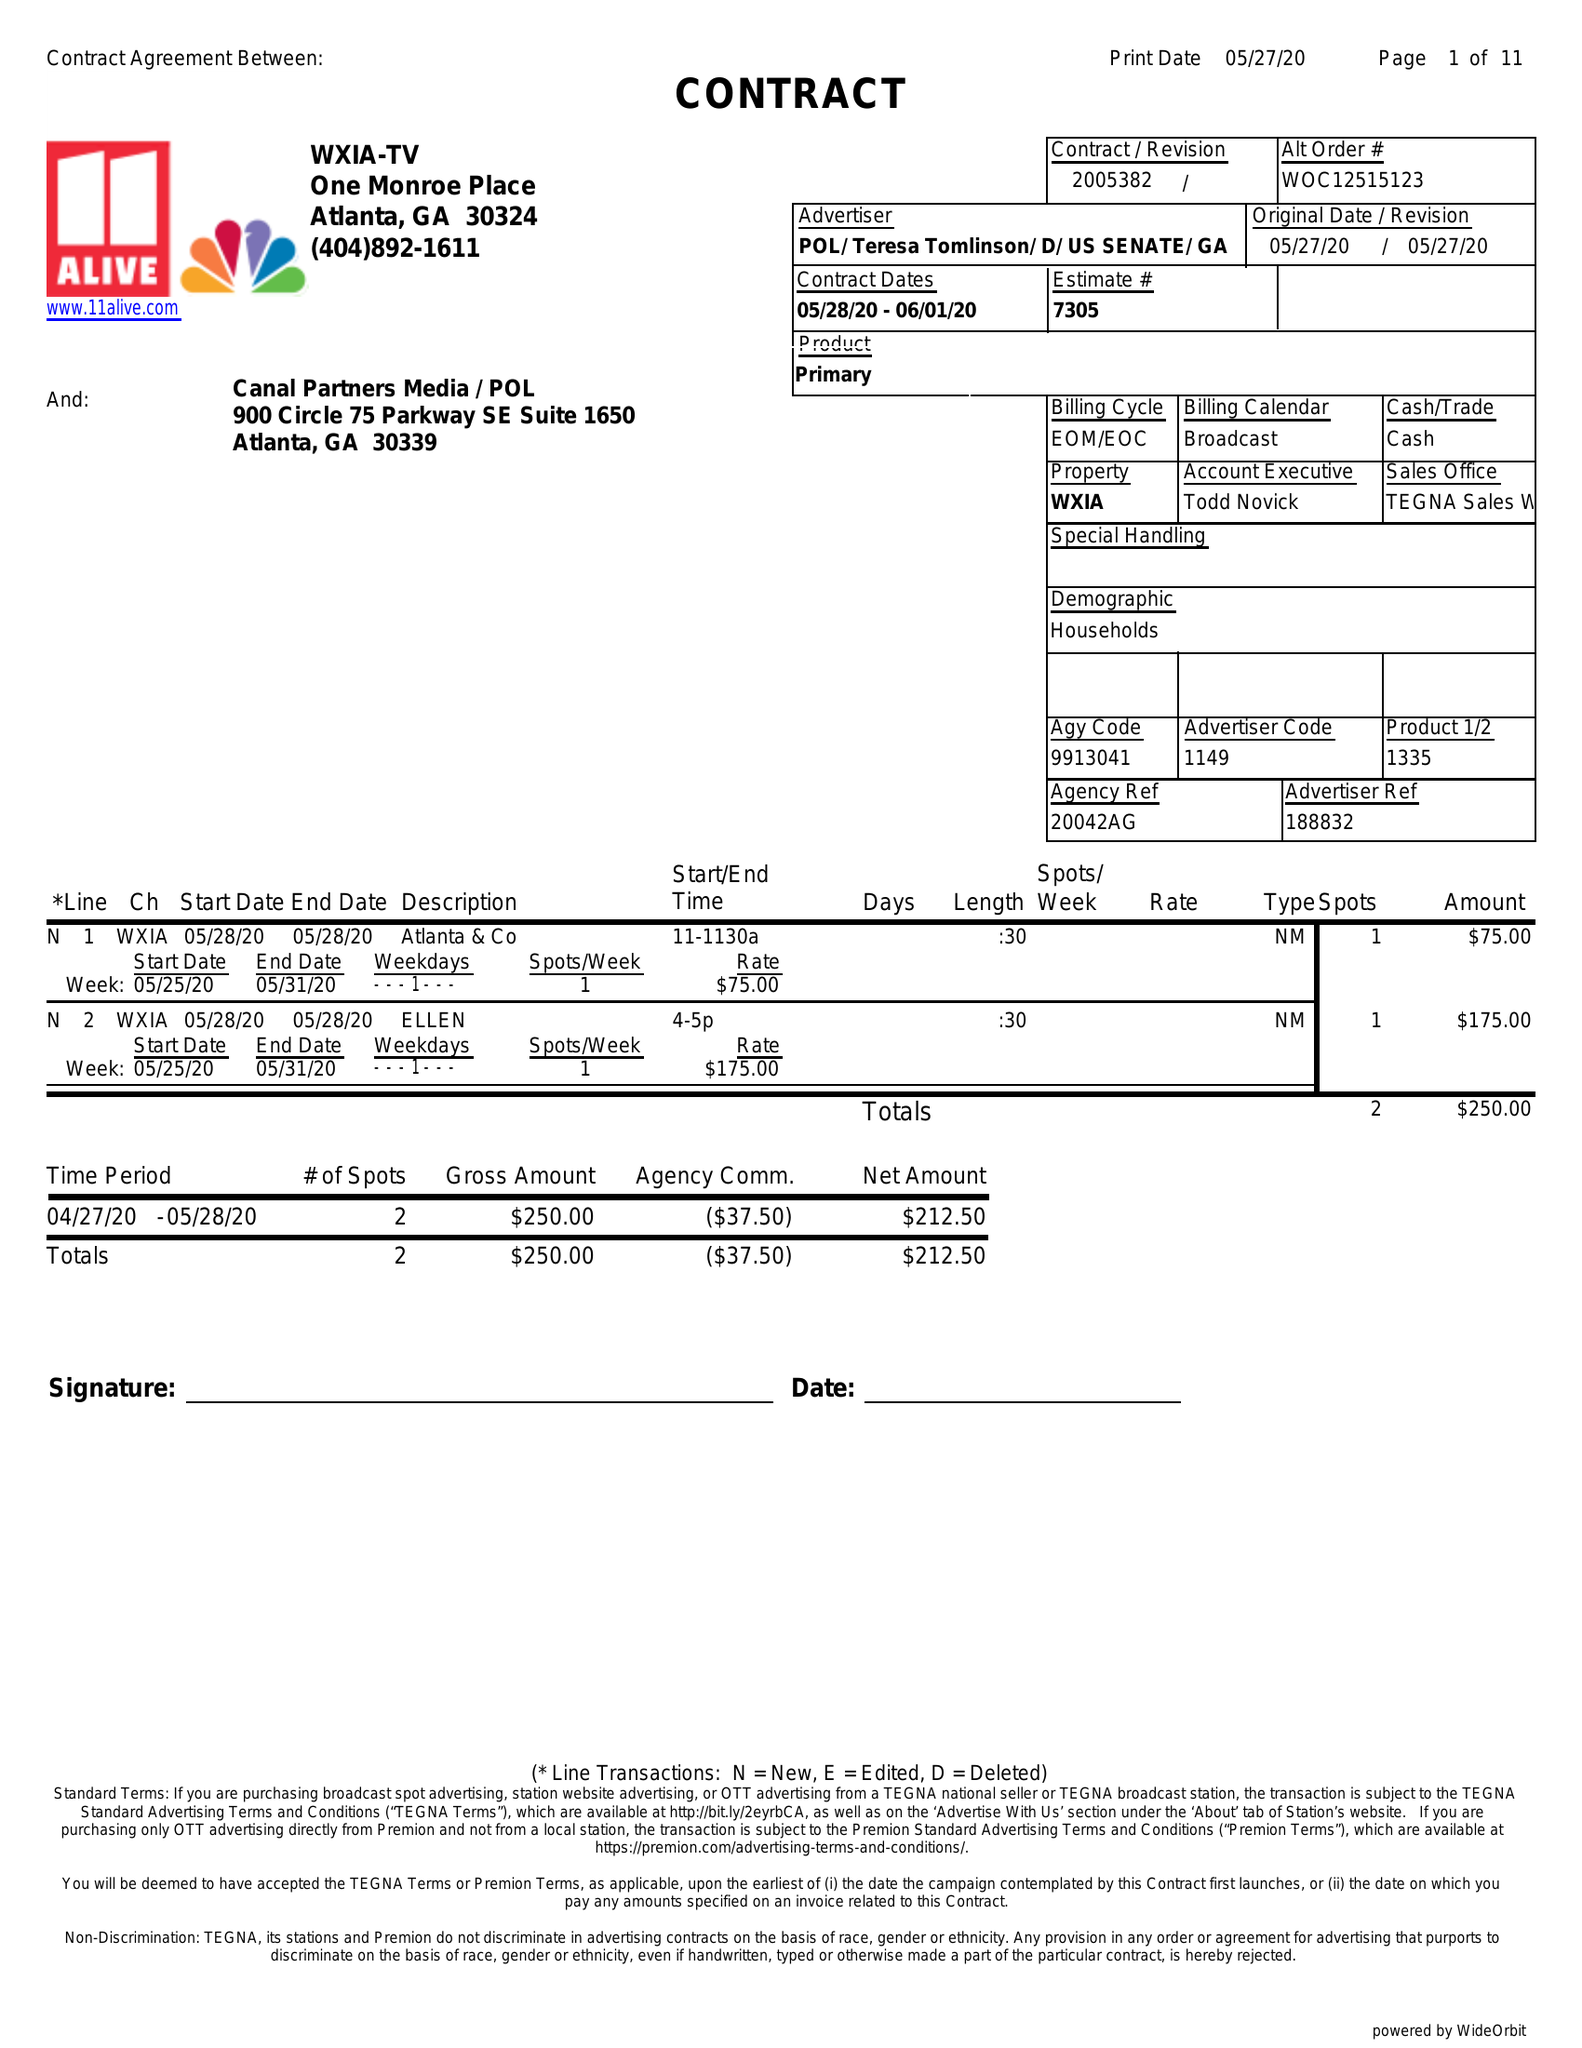What is the value for the flight_from?
Answer the question using a single word or phrase. 05/28/20 